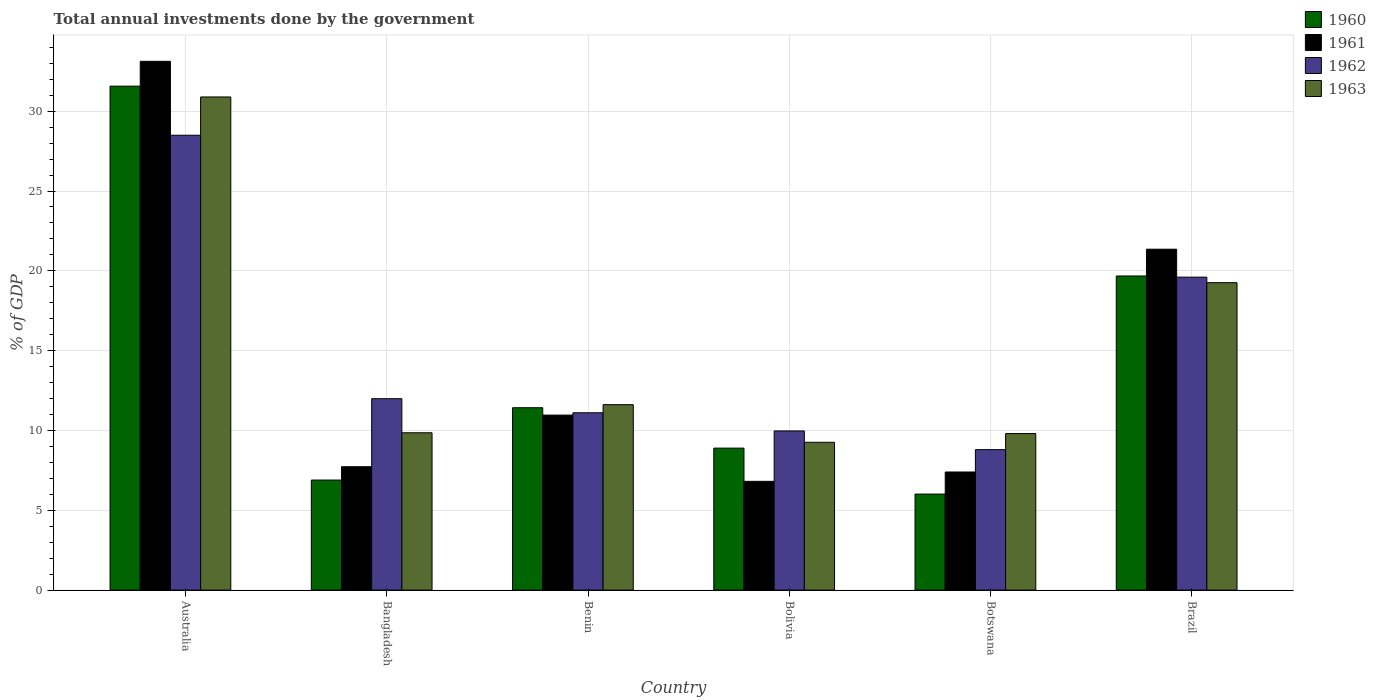Are the number of bars per tick equal to the number of legend labels?
Keep it short and to the point. Yes. Are the number of bars on each tick of the X-axis equal?
Offer a very short reply. Yes. How many bars are there on the 5th tick from the right?
Provide a short and direct response. 4. What is the label of the 5th group of bars from the left?
Your answer should be compact. Botswana. In how many cases, is the number of bars for a given country not equal to the number of legend labels?
Give a very brief answer. 0. What is the total annual investments done by the government in 1963 in Benin?
Provide a short and direct response. 11.62. Across all countries, what is the maximum total annual investments done by the government in 1962?
Offer a terse response. 28.49. Across all countries, what is the minimum total annual investments done by the government in 1963?
Your answer should be very brief. 9.26. In which country was the total annual investments done by the government in 1961 maximum?
Your answer should be very brief. Australia. In which country was the total annual investments done by the government in 1960 minimum?
Offer a very short reply. Botswana. What is the total total annual investments done by the government in 1962 in the graph?
Give a very brief answer. 89.97. What is the difference between the total annual investments done by the government in 1960 in Bolivia and that in Botswana?
Your answer should be very brief. 2.88. What is the difference between the total annual investments done by the government in 1962 in Brazil and the total annual investments done by the government in 1960 in Bangladesh?
Offer a terse response. 12.71. What is the average total annual investments done by the government in 1962 per country?
Provide a short and direct response. 14.99. What is the difference between the total annual investments done by the government of/in 1962 and total annual investments done by the government of/in 1963 in Australia?
Give a very brief answer. -2.4. In how many countries, is the total annual investments done by the government in 1960 greater than 3 %?
Keep it short and to the point. 6. What is the ratio of the total annual investments done by the government in 1962 in Bolivia to that in Botswana?
Keep it short and to the point. 1.13. What is the difference between the highest and the second highest total annual investments done by the government in 1961?
Offer a very short reply. 22.16. What is the difference between the highest and the lowest total annual investments done by the government in 1962?
Make the answer very short. 19.7. What does the 1st bar from the left in Brazil represents?
Your response must be concise. 1960. How many bars are there?
Make the answer very short. 24. Are all the bars in the graph horizontal?
Ensure brevity in your answer.  No. Does the graph contain any zero values?
Provide a succinct answer. No. Where does the legend appear in the graph?
Offer a terse response. Top right. What is the title of the graph?
Offer a very short reply. Total annual investments done by the government. Does "1988" appear as one of the legend labels in the graph?
Ensure brevity in your answer.  No. What is the label or title of the X-axis?
Provide a succinct answer. Country. What is the label or title of the Y-axis?
Your answer should be compact. % of GDP. What is the % of GDP of 1960 in Australia?
Your response must be concise. 31.57. What is the % of GDP in 1961 in Australia?
Offer a terse response. 33.13. What is the % of GDP in 1962 in Australia?
Offer a very short reply. 28.49. What is the % of GDP in 1963 in Australia?
Make the answer very short. 30.89. What is the % of GDP in 1960 in Bangladesh?
Keep it short and to the point. 6.89. What is the % of GDP of 1961 in Bangladesh?
Your answer should be compact. 7.73. What is the % of GDP of 1962 in Bangladesh?
Offer a very short reply. 11.99. What is the % of GDP in 1963 in Bangladesh?
Your answer should be very brief. 9.86. What is the % of GDP in 1960 in Benin?
Your response must be concise. 11.42. What is the % of GDP in 1961 in Benin?
Ensure brevity in your answer.  10.96. What is the % of GDP of 1962 in Benin?
Ensure brevity in your answer.  11.11. What is the % of GDP in 1963 in Benin?
Offer a terse response. 11.62. What is the % of GDP of 1960 in Bolivia?
Give a very brief answer. 8.89. What is the % of GDP in 1961 in Bolivia?
Offer a very short reply. 6.81. What is the % of GDP in 1962 in Bolivia?
Give a very brief answer. 9.97. What is the % of GDP in 1963 in Bolivia?
Provide a short and direct response. 9.26. What is the % of GDP of 1960 in Botswana?
Offer a very short reply. 6.02. What is the % of GDP of 1961 in Botswana?
Provide a short and direct response. 7.4. What is the % of GDP of 1962 in Botswana?
Offer a very short reply. 8.8. What is the % of GDP of 1963 in Botswana?
Make the answer very short. 9.81. What is the % of GDP in 1960 in Brazil?
Offer a very short reply. 19.68. What is the % of GDP in 1961 in Brazil?
Give a very brief answer. 21.36. What is the % of GDP in 1962 in Brazil?
Offer a very short reply. 19.6. What is the % of GDP in 1963 in Brazil?
Give a very brief answer. 19.26. Across all countries, what is the maximum % of GDP in 1960?
Offer a very short reply. 31.57. Across all countries, what is the maximum % of GDP of 1961?
Keep it short and to the point. 33.13. Across all countries, what is the maximum % of GDP in 1962?
Make the answer very short. 28.49. Across all countries, what is the maximum % of GDP in 1963?
Your answer should be very brief. 30.89. Across all countries, what is the minimum % of GDP of 1960?
Offer a very short reply. 6.02. Across all countries, what is the minimum % of GDP of 1961?
Your answer should be compact. 6.81. Across all countries, what is the minimum % of GDP in 1962?
Provide a short and direct response. 8.8. Across all countries, what is the minimum % of GDP of 1963?
Give a very brief answer. 9.26. What is the total % of GDP in 1960 in the graph?
Your answer should be very brief. 84.48. What is the total % of GDP of 1961 in the graph?
Provide a short and direct response. 87.39. What is the total % of GDP of 1962 in the graph?
Ensure brevity in your answer.  89.97. What is the total % of GDP of 1963 in the graph?
Provide a short and direct response. 90.69. What is the difference between the % of GDP in 1960 in Australia and that in Bangladesh?
Provide a short and direct response. 24.68. What is the difference between the % of GDP in 1961 in Australia and that in Bangladesh?
Keep it short and to the point. 25.4. What is the difference between the % of GDP in 1962 in Australia and that in Bangladesh?
Your response must be concise. 16.5. What is the difference between the % of GDP of 1963 in Australia and that in Bangladesh?
Give a very brief answer. 21.04. What is the difference between the % of GDP in 1960 in Australia and that in Benin?
Provide a short and direct response. 20.15. What is the difference between the % of GDP in 1961 in Australia and that in Benin?
Offer a terse response. 22.16. What is the difference between the % of GDP in 1962 in Australia and that in Benin?
Offer a terse response. 17.39. What is the difference between the % of GDP of 1963 in Australia and that in Benin?
Your response must be concise. 19.28. What is the difference between the % of GDP in 1960 in Australia and that in Bolivia?
Provide a short and direct response. 22.68. What is the difference between the % of GDP in 1961 in Australia and that in Bolivia?
Give a very brief answer. 26.31. What is the difference between the % of GDP in 1962 in Australia and that in Bolivia?
Give a very brief answer. 18.52. What is the difference between the % of GDP of 1963 in Australia and that in Bolivia?
Keep it short and to the point. 21.63. What is the difference between the % of GDP of 1960 in Australia and that in Botswana?
Your answer should be compact. 25.55. What is the difference between the % of GDP in 1961 in Australia and that in Botswana?
Make the answer very short. 25.73. What is the difference between the % of GDP in 1962 in Australia and that in Botswana?
Provide a short and direct response. 19.7. What is the difference between the % of GDP in 1963 in Australia and that in Botswana?
Provide a succinct answer. 21.09. What is the difference between the % of GDP of 1960 in Australia and that in Brazil?
Provide a succinct answer. 11.89. What is the difference between the % of GDP in 1961 in Australia and that in Brazil?
Give a very brief answer. 11.77. What is the difference between the % of GDP of 1962 in Australia and that in Brazil?
Your answer should be very brief. 8.89. What is the difference between the % of GDP in 1963 in Australia and that in Brazil?
Provide a short and direct response. 11.63. What is the difference between the % of GDP of 1960 in Bangladesh and that in Benin?
Keep it short and to the point. -4.53. What is the difference between the % of GDP of 1961 in Bangladesh and that in Benin?
Make the answer very short. -3.23. What is the difference between the % of GDP of 1962 in Bangladesh and that in Benin?
Give a very brief answer. 0.88. What is the difference between the % of GDP of 1963 in Bangladesh and that in Benin?
Your answer should be compact. -1.76. What is the difference between the % of GDP in 1961 in Bangladesh and that in Bolivia?
Keep it short and to the point. 0.92. What is the difference between the % of GDP in 1962 in Bangladesh and that in Bolivia?
Your answer should be compact. 2.02. What is the difference between the % of GDP of 1963 in Bangladesh and that in Bolivia?
Your response must be concise. 0.6. What is the difference between the % of GDP of 1960 in Bangladesh and that in Botswana?
Offer a terse response. 0.88. What is the difference between the % of GDP in 1961 in Bangladesh and that in Botswana?
Your answer should be very brief. 0.33. What is the difference between the % of GDP in 1962 in Bangladesh and that in Botswana?
Your response must be concise. 3.19. What is the difference between the % of GDP of 1963 in Bangladesh and that in Botswana?
Make the answer very short. 0.05. What is the difference between the % of GDP in 1960 in Bangladesh and that in Brazil?
Your response must be concise. -12.78. What is the difference between the % of GDP in 1961 in Bangladesh and that in Brazil?
Keep it short and to the point. -13.63. What is the difference between the % of GDP of 1962 in Bangladesh and that in Brazil?
Ensure brevity in your answer.  -7.61. What is the difference between the % of GDP in 1963 in Bangladesh and that in Brazil?
Your answer should be very brief. -9.4. What is the difference between the % of GDP in 1960 in Benin and that in Bolivia?
Your answer should be compact. 2.53. What is the difference between the % of GDP in 1961 in Benin and that in Bolivia?
Offer a terse response. 4.15. What is the difference between the % of GDP in 1962 in Benin and that in Bolivia?
Give a very brief answer. 1.14. What is the difference between the % of GDP in 1963 in Benin and that in Bolivia?
Ensure brevity in your answer.  2.36. What is the difference between the % of GDP of 1960 in Benin and that in Botswana?
Provide a succinct answer. 5.41. What is the difference between the % of GDP in 1961 in Benin and that in Botswana?
Keep it short and to the point. 3.56. What is the difference between the % of GDP of 1962 in Benin and that in Botswana?
Make the answer very short. 2.31. What is the difference between the % of GDP in 1963 in Benin and that in Botswana?
Offer a very short reply. 1.81. What is the difference between the % of GDP in 1960 in Benin and that in Brazil?
Keep it short and to the point. -8.25. What is the difference between the % of GDP of 1961 in Benin and that in Brazil?
Give a very brief answer. -10.39. What is the difference between the % of GDP of 1962 in Benin and that in Brazil?
Ensure brevity in your answer.  -8.5. What is the difference between the % of GDP in 1963 in Benin and that in Brazil?
Ensure brevity in your answer.  -7.64. What is the difference between the % of GDP in 1960 in Bolivia and that in Botswana?
Offer a very short reply. 2.88. What is the difference between the % of GDP of 1961 in Bolivia and that in Botswana?
Provide a succinct answer. -0.59. What is the difference between the % of GDP of 1962 in Bolivia and that in Botswana?
Ensure brevity in your answer.  1.17. What is the difference between the % of GDP in 1963 in Bolivia and that in Botswana?
Your answer should be compact. -0.55. What is the difference between the % of GDP in 1960 in Bolivia and that in Brazil?
Provide a succinct answer. -10.78. What is the difference between the % of GDP in 1961 in Bolivia and that in Brazil?
Offer a very short reply. -14.54. What is the difference between the % of GDP of 1962 in Bolivia and that in Brazil?
Give a very brief answer. -9.63. What is the difference between the % of GDP in 1963 in Bolivia and that in Brazil?
Make the answer very short. -10. What is the difference between the % of GDP in 1960 in Botswana and that in Brazil?
Provide a short and direct response. -13.66. What is the difference between the % of GDP of 1961 in Botswana and that in Brazil?
Make the answer very short. -13.96. What is the difference between the % of GDP in 1962 in Botswana and that in Brazil?
Your answer should be very brief. -10.81. What is the difference between the % of GDP of 1963 in Botswana and that in Brazil?
Your answer should be compact. -9.45. What is the difference between the % of GDP of 1960 in Australia and the % of GDP of 1961 in Bangladesh?
Your answer should be very brief. 23.84. What is the difference between the % of GDP in 1960 in Australia and the % of GDP in 1962 in Bangladesh?
Keep it short and to the point. 19.58. What is the difference between the % of GDP in 1960 in Australia and the % of GDP in 1963 in Bangladesh?
Provide a short and direct response. 21.71. What is the difference between the % of GDP of 1961 in Australia and the % of GDP of 1962 in Bangladesh?
Provide a succinct answer. 21.14. What is the difference between the % of GDP of 1961 in Australia and the % of GDP of 1963 in Bangladesh?
Provide a succinct answer. 23.27. What is the difference between the % of GDP in 1962 in Australia and the % of GDP in 1963 in Bangladesh?
Your answer should be compact. 18.64. What is the difference between the % of GDP of 1960 in Australia and the % of GDP of 1961 in Benin?
Provide a short and direct response. 20.61. What is the difference between the % of GDP of 1960 in Australia and the % of GDP of 1962 in Benin?
Offer a terse response. 20.46. What is the difference between the % of GDP in 1960 in Australia and the % of GDP in 1963 in Benin?
Provide a short and direct response. 19.95. What is the difference between the % of GDP of 1961 in Australia and the % of GDP of 1962 in Benin?
Give a very brief answer. 22.02. What is the difference between the % of GDP in 1961 in Australia and the % of GDP in 1963 in Benin?
Provide a short and direct response. 21.51. What is the difference between the % of GDP in 1962 in Australia and the % of GDP in 1963 in Benin?
Your answer should be very brief. 16.88. What is the difference between the % of GDP of 1960 in Australia and the % of GDP of 1961 in Bolivia?
Your answer should be very brief. 24.76. What is the difference between the % of GDP in 1960 in Australia and the % of GDP in 1962 in Bolivia?
Keep it short and to the point. 21.6. What is the difference between the % of GDP in 1960 in Australia and the % of GDP in 1963 in Bolivia?
Make the answer very short. 22.31. What is the difference between the % of GDP in 1961 in Australia and the % of GDP in 1962 in Bolivia?
Your response must be concise. 23.16. What is the difference between the % of GDP of 1961 in Australia and the % of GDP of 1963 in Bolivia?
Offer a very short reply. 23.87. What is the difference between the % of GDP in 1962 in Australia and the % of GDP in 1963 in Bolivia?
Make the answer very short. 19.23. What is the difference between the % of GDP of 1960 in Australia and the % of GDP of 1961 in Botswana?
Your response must be concise. 24.17. What is the difference between the % of GDP of 1960 in Australia and the % of GDP of 1962 in Botswana?
Your answer should be compact. 22.77. What is the difference between the % of GDP in 1960 in Australia and the % of GDP in 1963 in Botswana?
Your answer should be compact. 21.76. What is the difference between the % of GDP in 1961 in Australia and the % of GDP in 1962 in Botswana?
Offer a terse response. 24.33. What is the difference between the % of GDP of 1961 in Australia and the % of GDP of 1963 in Botswana?
Your answer should be compact. 23.32. What is the difference between the % of GDP in 1962 in Australia and the % of GDP in 1963 in Botswana?
Provide a short and direct response. 18.69. What is the difference between the % of GDP of 1960 in Australia and the % of GDP of 1961 in Brazil?
Give a very brief answer. 10.21. What is the difference between the % of GDP of 1960 in Australia and the % of GDP of 1962 in Brazil?
Make the answer very short. 11.97. What is the difference between the % of GDP in 1960 in Australia and the % of GDP in 1963 in Brazil?
Your answer should be very brief. 12.31. What is the difference between the % of GDP of 1961 in Australia and the % of GDP of 1962 in Brazil?
Give a very brief answer. 13.52. What is the difference between the % of GDP in 1961 in Australia and the % of GDP in 1963 in Brazil?
Offer a very short reply. 13.87. What is the difference between the % of GDP of 1962 in Australia and the % of GDP of 1963 in Brazil?
Your response must be concise. 9.24. What is the difference between the % of GDP of 1960 in Bangladesh and the % of GDP of 1961 in Benin?
Provide a short and direct response. -4.07. What is the difference between the % of GDP in 1960 in Bangladesh and the % of GDP in 1962 in Benin?
Keep it short and to the point. -4.21. What is the difference between the % of GDP of 1960 in Bangladesh and the % of GDP of 1963 in Benin?
Your response must be concise. -4.72. What is the difference between the % of GDP in 1961 in Bangladesh and the % of GDP in 1962 in Benin?
Your answer should be compact. -3.38. What is the difference between the % of GDP in 1961 in Bangladesh and the % of GDP in 1963 in Benin?
Ensure brevity in your answer.  -3.89. What is the difference between the % of GDP in 1962 in Bangladesh and the % of GDP in 1963 in Benin?
Provide a succinct answer. 0.37. What is the difference between the % of GDP in 1960 in Bangladesh and the % of GDP in 1961 in Bolivia?
Give a very brief answer. 0.08. What is the difference between the % of GDP of 1960 in Bangladesh and the % of GDP of 1962 in Bolivia?
Give a very brief answer. -3.08. What is the difference between the % of GDP of 1960 in Bangladesh and the % of GDP of 1963 in Bolivia?
Make the answer very short. -2.37. What is the difference between the % of GDP of 1961 in Bangladesh and the % of GDP of 1962 in Bolivia?
Keep it short and to the point. -2.24. What is the difference between the % of GDP in 1961 in Bangladesh and the % of GDP in 1963 in Bolivia?
Make the answer very short. -1.53. What is the difference between the % of GDP in 1962 in Bangladesh and the % of GDP in 1963 in Bolivia?
Make the answer very short. 2.73. What is the difference between the % of GDP of 1960 in Bangladesh and the % of GDP of 1961 in Botswana?
Your answer should be compact. -0.51. What is the difference between the % of GDP in 1960 in Bangladesh and the % of GDP in 1962 in Botswana?
Offer a terse response. -1.9. What is the difference between the % of GDP of 1960 in Bangladesh and the % of GDP of 1963 in Botswana?
Make the answer very short. -2.91. What is the difference between the % of GDP in 1961 in Bangladesh and the % of GDP in 1962 in Botswana?
Provide a short and direct response. -1.07. What is the difference between the % of GDP in 1961 in Bangladesh and the % of GDP in 1963 in Botswana?
Ensure brevity in your answer.  -2.08. What is the difference between the % of GDP in 1962 in Bangladesh and the % of GDP in 1963 in Botswana?
Provide a short and direct response. 2.18. What is the difference between the % of GDP of 1960 in Bangladesh and the % of GDP of 1961 in Brazil?
Provide a short and direct response. -14.46. What is the difference between the % of GDP of 1960 in Bangladesh and the % of GDP of 1962 in Brazil?
Make the answer very short. -12.71. What is the difference between the % of GDP in 1960 in Bangladesh and the % of GDP in 1963 in Brazil?
Give a very brief answer. -12.37. What is the difference between the % of GDP of 1961 in Bangladesh and the % of GDP of 1962 in Brazil?
Your answer should be very brief. -11.88. What is the difference between the % of GDP in 1961 in Bangladesh and the % of GDP in 1963 in Brazil?
Your response must be concise. -11.53. What is the difference between the % of GDP in 1962 in Bangladesh and the % of GDP in 1963 in Brazil?
Offer a very short reply. -7.27. What is the difference between the % of GDP in 1960 in Benin and the % of GDP in 1961 in Bolivia?
Offer a terse response. 4.61. What is the difference between the % of GDP in 1960 in Benin and the % of GDP in 1962 in Bolivia?
Ensure brevity in your answer.  1.45. What is the difference between the % of GDP in 1960 in Benin and the % of GDP in 1963 in Bolivia?
Your answer should be compact. 2.16. What is the difference between the % of GDP of 1961 in Benin and the % of GDP of 1962 in Bolivia?
Ensure brevity in your answer.  0.99. What is the difference between the % of GDP in 1961 in Benin and the % of GDP in 1963 in Bolivia?
Provide a succinct answer. 1.7. What is the difference between the % of GDP of 1962 in Benin and the % of GDP of 1963 in Bolivia?
Your response must be concise. 1.85. What is the difference between the % of GDP of 1960 in Benin and the % of GDP of 1961 in Botswana?
Your response must be concise. 4.03. What is the difference between the % of GDP in 1960 in Benin and the % of GDP in 1962 in Botswana?
Make the answer very short. 2.63. What is the difference between the % of GDP in 1960 in Benin and the % of GDP in 1963 in Botswana?
Offer a terse response. 1.62. What is the difference between the % of GDP of 1961 in Benin and the % of GDP of 1962 in Botswana?
Make the answer very short. 2.16. What is the difference between the % of GDP in 1961 in Benin and the % of GDP in 1963 in Botswana?
Your response must be concise. 1.16. What is the difference between the % of GDP in 1962 in Benin and the % of GDP in 1963 in Botswana?
Your response must be concise. 1.3. What is the difference between the % of GDP in 1960 in Benin and the % of GDP in 1961 in Brazil?
Your response must be concise. -9.93. What is the difference between the % of GDP of 1960 in Benin and the % of GDP of 1962 in Brazil?
Your answer should be very brief. -8.18. What is the difference between the % of GDP of 1960 in Benin and the % of GDP of 1963 in Brazil?
Make the answer very short. -7.83. What is the difference between the % of GDP in 1961 in Benin and the % of GDP in 1962 in Brazil?
Provide a short and direct response. -8.64. What is the difference between the % of GDP of 1961 in Benin and the % of GDP of 1963 in Brazil?
Your response must be concise. -8.3. What is the difference between the % of GDP in 1962 in Benin and the % of GDP in 1963 in Brazil?
Provide a succinct answer. -8.15. What is the difference between the % of GDP of 1960 in Bolivia and the % of GDP of 1961 in Botswana?
Your response must be concise. 1.49. What is the difference between the % of GDP of 1960 in Bolivia and the % of GDP of 1962 in Botswana?
Offer a terse response. 0.1. What is the difference between the % of GDP in 1960 in Bolivia and the % of GDP in 1963 in Botswana?
Offer a very short reply. -0.91. What is the difference between the % of GDP in 1961 in Bolivia and the % of GDP in 1962 in Botswana?
Ensure brevity in your answer.  -1.99. What is the difference between the % of GDP of 1961 in Bolivia and the % of GDP of 1963 in Botswana?
Ensure brevity in your answer.  -2.99. What is the difference between the % of GDP in 1962 in Bolivia and the % of GDP in 1963 in Botswana?
Your response must be concise. 0.16. What is the difference between the % of GDP in 1960 in Bolivia and the % of GDP in 1961 in Brazil?
Provide a short and direct response. -12.46. What is the difference between the % of GDP of 1960 in Bolivia and the % of GDP of 1962 in Brazil?
Your answer should be very brief. -10.71. What is the difference between the % of GDP in 1960 in Bolivia and the % of GDP in 1963 in Brazil?
Give a very brief answer. -10.37. What is the difference between the % of GDP in 1961 in Bolivia and the % of GDP in 1962 in Brazil?
Give a very brief answer. -12.79. What is the difference between the % of GDP of 1961 in Bolivia and the % of GDP of 1963 in Brazil?
Provide a succinct answer. -12.45. What is the difference between the % of GDP in 1962 in Bolivia and the % of GDP in 1963 in Brazil?
Keep it short and to the point. -9.29. What is the difference between the % of GDP of 1960 in Botswana and the % of GDP of 1961 in Brazil?
Make the answer very short. -15.34. What is the difference between the % of GDP of 1960 in Botswana and the % of GDP of 1962 in Brazil?
Offer a very short reply. -13.59. What is the difference between the % of GDP of 1960 in Botswana and the % of GDP of 1963 in Brazil?
Give a very brief answer. -13.24. What is the difference between the % of GDP in 1961 in Botswana and the % of GDP in 1962 in Brazil?
Your answer should be very brief. -12.21. What is the difference between the % of GDP of 1961 in Botswana and the % of GDP of 1963 in Brazil?
Keep it short and to the point. -11.86. What is the difference between the % of GDP of 1962 in Botswana and the % of GDP of 1963 in Brazil?
Keep it short and to the point. -10.46. What is the average % of GDP of 1960 per country?
Give a very brief answer. 14.08. What is the average % of GDP of 1961 per country?
Offer a terse response. 14.56. What is the average % of GDP in 1962 per country?
Provide a succinct answer. 14.99. What is the average % of GDP of 1963 per country?
Offer a very short reply. 15.12. What is the difference between the % of GDP of 1960 and % of GDP of 1961 in Australia?
Provide a succinct answer. -1.56. What is the difference between the % of GDP in 1960 and % of GDP in 1962 in Australia?
Offer a very short reply. 3.08. What is the difference between the % of GDP in 1960 and % of GDP in 1963 in Australia?
Provide a succinct answer. 0.68. What is the difference between the % of GDP of 1961 and % of GDP of 1962 in Australia?
Your response must be concise. 4.63. What is the difference between the % of GDP in 1961 and % of GDP in 1963 in Australia?
Provide a short and direct response. 2.23. What is the difference between the % of GDP in 1962 and % of GDP in 1963 in Australia?
Your response must be concise. -2.4. What is the difference between the % of GDP of 1960 and % of GDP of 1961 in Bangladesh?
Provide a short and direct response. -0.84. What is the difference between the % of GDP of 1960 and % of GDP of 1962 in Bangladesh?
Offer a terse response. -5.1. What is the difference between the % of GDP of 1960 and % of GDP of 1963 in Bangladesh?
Provide a short and direct response. -2.96. What is the difference between the % of GDP of 1961 and % of GDP of 1962 in Bangladesh?
Your answer should be very brief. -4.26. What is the difference between the % of GDP in 1961 and % of GDP in 1963 in Bangladesh?
Your answer should be very brief. -2.13. What is the difference between the % of GDP in 1962 and % of GDP in 1963 in Bangladesh?
Provide a succinct answer. 2.13. What is the difference between the % of GDP in 1960 and % of GDP in 1961 in Benin?
Offer a very short reply. 0.46. What is the difference between the % of GDP in 1960 and % of GDP in 1962 in Benin?
Offer a terse response. 0.32. What is the difference between the % of GDP of 1960 and % of GDP of 1963 in Benin?
Keep it short and to the point. -0.19. What is the difference between the % of GDP in 1961 and % of GDP in 1962 in Benin?
Your answer should be compact. -0.15. What is the difference between the % of GDP of 1961 and % of GDP of 1963 in Benin?
Keep it short and to the point. -0.65. What is the difference between the % of GDP of 1962 and % of GDP of 1963 in Benin?
Keep it short and to the point. -0.51. What is the difference between the % of GDP of 1960 and % of GDP of 1961 in Bolivia?
Keep it short and to the point. 2.08. What is the difference between the % of GDP in 1960 and % of GDP in 1962 in Bolivia?
Give a very brief answer. -1.08. What is the difference between the % of GDP of 1960 and % of GDP of 1963 in Bolivia?
Your response must be concise. -0.37. What is the difference between the % of GDP in 1961 and % of GDP in 1962 in Bolivia?
Your answer should be compact. -3.16. What is the difference between the % of GDP of 1961 and % of GDP of 1963 in Bolivia?
Give a very brief answer. -2.45. What is the difference between the % of GDP of 1962 and % of GDP of 1963 in Bolivia?
Offer a terse response. 0.71. What is the difference between the % of GDP in 1960 and % of GDP in 1961 in Botswana?
Your answer should be compact. -1.38. What is the difference between the % of GDP in 1960 and % of GDP in 1962 in Botswana?
Provide a succinct answer. -2.78. What is the difference between the % of GDP of 1960 and % of GDP of 1963 in Botswana?
Give a very brief answer. -3.79. What is the difference between the % of GDP of 1961 and % of GDP of 1962 in Botswana?
Provide a succinct answer. -1.4. What is the difference between the % of GDP of 1961 and % of GDP of 1963 in Botswana?
Provide a short and direct response. -2.41. What is the difference between the % of GDP in 1962 and % of GDP in 1963 in Botswana?
Provide a succinct answer. -1.01. What is the difference between the % of GDP in 1960 and % of GDP in 1961 in Brazil?
Make the answer very short. -1.68. What is the difference between the % of GDP of 1960 and % of GDP of 1962 in Brazil?
Ensure brevity in your answer.  0.07. What is the difference between the % of GDP of 1960 and % of GDP of 1963 in Brazil?
Provide a succinct answer. 0.42. What is the difference between the % of GDP in 1961 and % of GDP in 1962 in Brazil?
Provide a short and direct response. 1.75. What is the difference between the % of GDP in 1961 and % of GDP in 1963 in Brazil?
Offer a terse response. 2.1. What is the difference between the % of GDP in 1962 and % of GDP in 1963 in Brazil?
Your response must be concise. 0.34. What is the ratio of the % of GDP of 1960 in Australia to that in Bangladesh?
Ensure brevity in your answer.  4.58. What is the ratio of the % of GDP of 1961 in Australia to that in Bangladesh?
Give a very brief answer. 4.29. What is the ratio of the % of GDP in 1962 in Australia to that in Bangladesh?
Make the answer very short. 2.38. What is the ratio of the % of GDP in 1963 in Australia to that in Bangladesh?
Give a very brief answer. 3.13. What is the ratio of the % of GDP of 1960 in Australia to that in Benin?
Your answer should be compact. 2.76. What is the ratio of the % of GDP of 1961 in Australia to that in Benin?
Your answer should be compact. 3.02. What is the ratio of the % of GDP in 1962 in Australia to that in Benin?
Ensure brevity in your answer.  2.56. What is the ratio of the % of GDP in 1963 in Australia to that in Benin?
Your response must be concise. 2.66. What is the ratio of the % of GDP of 1960 in Australia to that in Bolivia?
Provide a short and direct response. 3.55. What is the ratio of the % of GDP of 1961 in Australia to that in Bolivia?
Provide a succinct answer. 4.86. What is the ratio of the % of GDP of 1962 in Australia to that in Bolivia?
Your answer should be compact. 2.86. What is the ratio of the % of GDP of 1963 in Australia to that in Bolivia?
Offer a terse response. 3.34. What is the ratio of the % of GDP of 1960 in Australia to that in Botswana?
Your answer should be compact. 5.25. What is the ratio of the % of GDP in 1961 in Australia to that in Botswana?
Provide a short and direct response. 4.48. What is the ratio of the % of GDP in 1962 in Australia to that in Botswana?
Provide a short and direct response. 3.24. What is the ratio of the % of GDP of 1963 in Australia to that in Botswana?
Give a very brief answer. 3.15. What is the ratio of the % of GDP of 1960 in Australia to that in Brazil?
Your answer should be very brief. 1.6. What is the ratio of the % of GDP in 1961 in Australia to that in Brazil?
Make the answer very short. 1.55. What is the ratio of the % of GDP in 1962 in Australia to that in Brazil?
Your response must be concise. 1.45. What is the ratio of the % of GDP in 1963 in Australia to that in Brazil?
Provide a short and direct response. 1.6. What is the ratio of the % of GDP of 1960 in Bangladesh to that in Benin?
Your answer should be very brief. 0.6. What is the ratio of the % of GDP in 1961 in Bangladesh to that in Benin?
Your answer should be compact. 0.71. What is the ratio of the % of GDP of 1962 in Bangladesh to that in Benin?
Provide a short and direct response. 1.08. What is the ratio of the % of GDP of 1963 in Bangladesh to that in Benin?
Provide a succinct answer. 0.85. What is the ratio of the % of GDP of 1960 in Bangladesh to that in Bolivia?
Offer a very short reply. 0.78. What is the ratio of the % of GDP in 1961 in Bangladesh to that in Bolivia?
Ensure brevity in your answer.  1.13. What is the ratio of the % of GDP in 1962 in Bangladesh to that in Bolivia?
Keep it short and to the point. 1.2. What is the ratio of the % of GDP of 1963 in Bangladesh to that in Bolivia?
Provide a short and direct response. 1.06. What is the ratio of the % of GDP in 1960 in Bangladesh to that in Botswana?
Your answer should be compact. 1.15. What is the ratio of the % of GDP in 1961 in Bangladesh to that in Botswana?
Your answer should be compact. 1.04. What is the ratio of the % of GDP in 1962 in Bangladesh to that in Botswana?
Your answer should be very brief. 1.36. What is the ratio of the % of GDP in 1963 in Bangladesh to that in Botswana?
Provide a short and direct response. 1. What is the ratio of the % of GDP in 1960 in Bangladesh to that in Brazil?
Your response must be concise. 0.35. What is the ratio of the % of GDP in 1961 in Bangladesh to that in Brazil?
Your response must be concise. 0.36. What is the ratio of the % of GDP of 1962 in Bangladesh to that in Brazil?
Your response must be concise. 0.61. What is the ratio of the % of GDP of 1963 in Bangladesh to that in Brazil?
Provide a short and direct response. 0.51. What is the ratio of the % of GDP of 1960 in Benin to that in Bolivia?
Offer a terse response. 1.28. What is the ratio of the % of GDP in 1961 in Benin to that in Bolivia?
Provide a short and direct response. 1.61. What is the ratio of the % of GDP of 1962 in Benin to that in Bolivia?
Provide a short and direct response. 1.11. What is the ratio of the % of GDP in 1963 in Benin to that in Bolivia?
Provide a short and direct response. 1.25. What is the ratio of the % of GDP of 1960 in Benin to that in Botswana?
Offer a very short reply. 1.9. What is the ratio of the % of GDP in 1961 in Benin to that in Botswana?
Your answer should be very brief. 1.48. What is the ratio of the % of GDP in 1962 in Benin to that in Botswana?
Offer a terse response. 1.26. What is the ratio of the % of GDP in 1963 in Benin to that in Botswana?
Provide a short and direct response. 1.18. What is the ratio of the % of GDP in 1960 in Benin to that in Brazil?
Provide a succinct answer. 0.58. What is the ratio of the % of GDP of 1961 in Benin to that in Brazil?
Make the answer very short. 0.51. What is the ratio of the % of GDP in 1962 in Benin to that in Brazil?
Offer a very short reply. 0.57. What is the ratio of the % of GDP in 1963 in Benin to that in Brazil?
Give a very brief answer. 0.6. What is the ratio of the % of GDP of 1960 in Bolivia to that in Botswana?
Make the answer very short. 1.48. What is the ratio of the % of GDP of 1961 in Bolivia to that in Botswana?
Offer a very short reply. 0.92. What is the ratio of the % of GDP in 1962 in Bolivia to that in Botswana?
Offer a terse response. 1.13. What is the ratio of the % of GDP of 1963 in Bolivia to that in Botswana?
Keep it short and to the point. 0.94. What is the ratio of the % of GDP of 1960 in Bolivia to that in Brazil?
Keep it short and to the point. 0.45. What is the ratio of the % of GDP of 1961 in Bolivia to that in Brazil?
Provide a succinct answer. 0.32. What is the ratio of the % of GDP of 1962 in Bolivia to that in Brazil?
Your response must be concise. 0.51. What is the ratio of the % of GDP in 1963 in Bolivia to that in Brazil?
Your answer should be very brief. 0.48. What is the ratio of the % of GDP of 1960 in Botswana to that in Brazil?
Give a very brief answer. 0.31. What is the ratio of the % of GDP in 1961 in Botswana to that in Brazil?
Offer a terse response. 0.35. What is the ratio of the % of GDP in 1962 in Botswana to that in Brazil?
Provide a short and direct response. 0.45. What is the ratio of the % of GDP of 1963 in Botswana to that in Brazil?
Provide a short and direct response. 0.51. What is the difference between the highest and the second highest % of GDP of 1960?
Your response must be concise. 11.89. What is the difference between the highest and the second highest % of GDP of 1961?
Provide a short and direct response. 11.77. What is the difference between the highest and the second highest % of GDP in 1962?
Keep it short and to the point. 8.89. What is the difference between the highest and the second highest % of GDP in 1963?
Provide a short and direct response. 11.63. What is the difference between the highest and the lowest % of GDP of 1960?
Offer a very short reply. 25.55. What is the difference between the highest and the lowest % of GDP of 1961?
Your answer should be very brief. 26.31. What is the difference between the highest and the lowest % of GDP in 1962?
Keep it short and to the point. 19.7. What is the difference between the highest and the lowest % of GDP of 1963?
Keep it short and to the point. 21.63. 